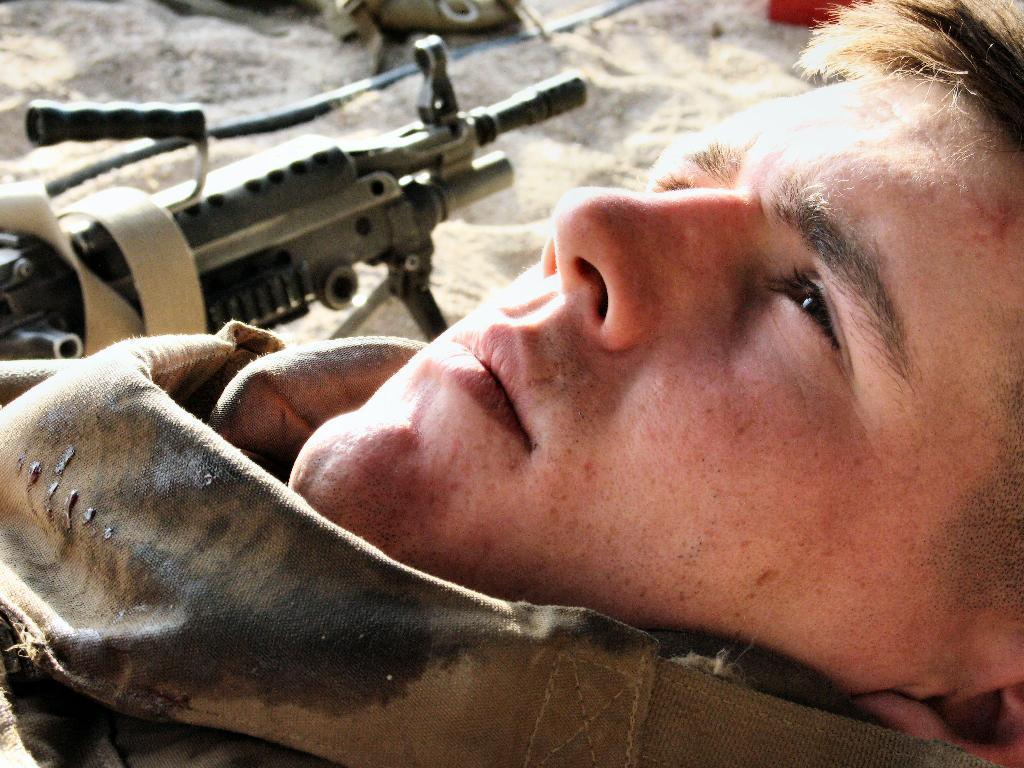What is the person in the image wearing? The person in the image is wearing a military dress. Can you describe any objects or features in the background of the image? Yes, there is a gun and sand visible in the background of the image. What type of wire can be seen connecting the person to the lake in the image? There is no wire connecting the person to a lake in the image. Can you tell me how many pens are visible in the image? There are no pens present in the image. 